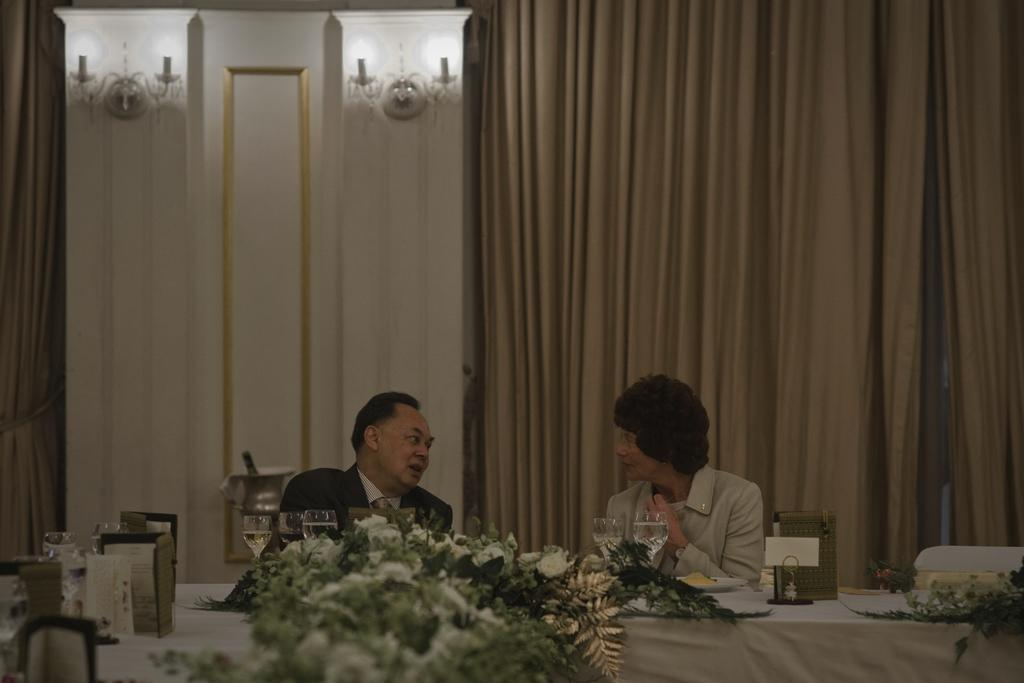Who is present in the image? There is a man and a woman in the image. What are the man and woman doing in the image? The man and woman are talking to each other in the image. Where are the man and woman located in the image? They are sitting at a table in the image. How many brothers does the toy have in the image? There is no toy present in the image, so it is not possible to determine how many brothers it might have. 